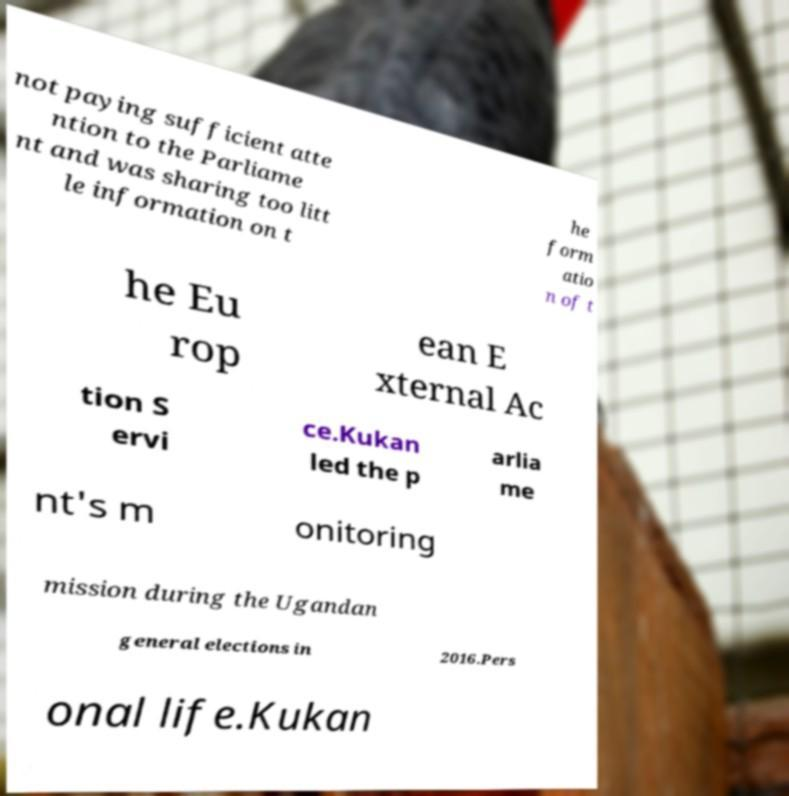There's text embedded in this image that I need extracted. Can you transcribe it verbatim? not paying sufficient atte ntion to the Parliame nt and was sharing too litt le information on t he form atio n of t he Eu rop ean E xternal Ac tion S ervi ce.Kukan led the p arlia me nt's m onitoring mission during the Ugandan general elections in 2016.Pers onal life.Kukan 